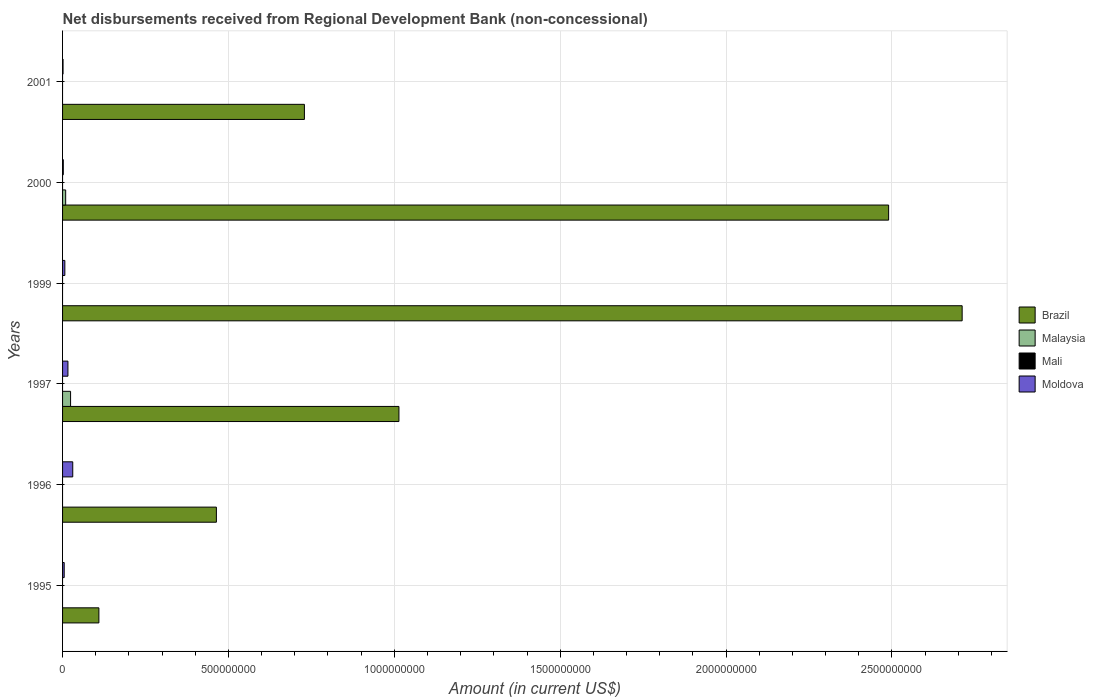How many different coloured bars are there?
Your answer should be very brief. 3. Are the number of bars per tick equal to the number of legend labels?
Your answer should be compact. No. Are the number of bars on each tick of the Y-axis equal?
Provide a succinct answer. No. How many bars are there on the 5th tick from the top?
Keep it short and to the point. 2. In how many cases, is the number of bars for a given year not equal to the number of legend labels?
Provide a short and direct response. 6. What is the amount of disbursements received from Regional Development Bank in Moldova in 1997?
Your response must be concise. 1.62e+07. Across all years, what is the maximum amount of disbursements received from Regional Development Bank in Brazil?
Ensure brevity in your answer.  2.71e+09. Across all years, what is the minimum amount of disbursements received from Regional Development Bank in Moldova?
Provide a succinct answer. 1.43e+06. What is the total amount of disbursements received from Regional Development Bank in Malaysia in the graph?
Make the answer very short. 3.35e+07. What is the difference between the amount of disbursements received from Regional Development Bank in Brazil in 1997 and that in 1999?
Make the answer very short. -1.70e+09. What is the difference between the amount of disbursements received from Regional Development Bank in Mali in 1996 and the amount of disbursements received from Regional Development Bank in Brazil in 1997?
Keep it short and to the point. -1.01e+09. In the year 2001, what is the difference between the amount of disbursements received from Regional Development Bank in Brazil and amount of disbursements received from Regional Development Bank in Moldova?
Provide a short and direct response. 7.28e+08. In how many years, is the amount of disbursements received from Regional Development Bank in Moldova greater than 300000000 US$?
Your answer should be very brief. 0. What is the ratio of the amount of disbursements received from Regional Development Bank in Moldova in 1995 to that in 1999?
Provide a short and direct response. 0.72. Is the amount of disbursements received from Regional Development Bank in Brazil in 1996 less than that in 1997?
Ensure brevity in your answer.  Yes. What is the difference between the highest and the second highest amount of disbursements received from Regional Development Bank in Moldova?
Your answer should be compact. 1.45e+07. What is the difference between the highest and the lowest amount of disbursements received from Regional Development Bank in Brazil?
Keep it short and to the point. 2.60e+09. Are all the bars in the graph horizontal?
Offer a terse response. Yes. What is the difference between two consecutive major ticks on the X-axis?
Provide a short and direct response. 5.00e+08. Does the graph contain any zero values?
Your response must be concise. Yes. Does the graph contain grids?
Offer a very short reply. Yes. How are the legend labels stacked?
Give a very brief answer. Vertical. What is the title of the graph?
Give a very brief answer. Net disbursements received from Regional Development Bank (non-concessional). Does "West Bank and Gaza" appear as one of the legend labels in the graph?
Provide a succinct answer. No. What is the label or title of the Y-axis?
Your answer should be very brief. Years. What is the Amount (in current US$) of Brazil in 1995?
Keep it short and to the point. 1.10e+08. What is the Amount (in current US$) of Malaysia in 1995?
Give a very brief answer. 0. What is the Amount (in current US$) in Mali in 1995?
Your answer should be compact. 0. What is the Amount (in current US$) in Moldova in 1995?
Give a very brief answer. 4.94e+06. What is the Amount (in current US$) of Brazil in 1996?
Your response must be concise. 4.64e+08. What is the Amount (in current US$) in Moldova in 1996?
Your answer should be compact. 3.07e+07. What is the Amount (in current US$) of Brazil in 1997?
Provide a succinct answer. 1.01e+09. What is the Amount (in current US$) in Malaysia in 1997?
Make the answer very short. 2.42e+07. What is the Amount (in current US$) of Moldova in 1997?
Make the answer very short. 1.62e+07. What is the Amount (in current US$) in Brazil in 1999?
Provide a succinct answer. 2.71e+09. What is the Amount (in current US$) in Mali in 1999?
Give a very brief answer. 0. What is the Amount (in current US$) of Moldova in 1999?
Provide a short and direct response. 6.86e+06. What is the Amount (in current US$) of Brazil in 2000?
Offer a very short reply. 2.49e+09. What is the Amount (in current US$) in Malaysia in 2000?
Ensure brevity in your answer.  9.38e+06. What is the Amount (in current US$) in Moldova in 2000?
Offer a very short reply. 2.23e+06. What is the Amount (in current US$) in Brazil in 2001?
Provide a succinct answer. 7.29e+08. What is the Amount (in current US$) of Malaysia in 2001?
Your answer should be very brief. 0. What is the Amount (in current US$) in Moldova in 2001?
Ensure brevity in your answer.  1.43e+06. Across all years, what is the maximum Amount (in current US$) of Brazil?
Your response must be concise. 2.71e+09. Across all years, what is the maximum Amount (in current US$) in Malaysia?
Make the answer very short. 2.42e+07. Across all years, what is the maximum Amount (in current US$) of Moldova?
Your answer should be very brief. 3.07e+07. Across all years, what is the minimum Amount (in current US$) of Brazil?
Offer a very short reply. 1.10e+08. Across all years, what is the minimum Amount (in current US$) of Malaysia?
Offer a very short reply. 0. Across all years, what is the minimum Amount (in current US$) of Moldova?
Offer a very short reply. 1.43e+06. What is the total Amount (in current US$) in Brazil in the graph?
Offer a terse response. 7.52e+09. What is the total Amount (in current US$) of Malaysia in the graph?
Provide a succinct answer. 3.35e+07. What is the total Amount (in current US$) of Moldova in the graph?
Provide a succinct answer. 6.23e+07. What is the difference between the Amount (in current US$) in Brazil in 1995 and that in 1996?
Provide a short and direct response. -3.54e+08. What is the difference between the Amount (in current US$) of Moldova in 1995 and that in 1996?
Your response must be concise. -2.58e+07. What is the difference between the Amount (in current US$) of Brazil in 1995 and that in 1997?
Your response must be concise. -9.04e+08. What is the difference between the Amount (in current US$) of Moldova in 1995 and that in 1997?
Ensure brevity in your answer.  -1.12e+07. What is the difference between the Amount (in current US$) of Brazil in 1995 and that in 1999?
Offer a very short reply. -2.60e+09. What is the difference between the Amount (in current US$) in Moldova in 1995 and that in 1999?
Make the answer very short. -1.91e+06. What is the difference between the Amount (in current US$) of Brazil in 1995 and that in 2000?
Your response must be concise. -2.38e+09. What is the difference between the Amount (in current US$) in Moldova in 1995 and that in 2000?
Offer a very short reply. 2.72e+06. What is the difference between the Amount (in current US$) in Brazil in 1995 and that in 2001?
Provide a short and direct response. -6.20e+08. What is the difference between the Amount (in current US$) in Moldova in 1995 and that in 2001?
Offer a very short reply. 3.52e+06. What is the difference between the Amount (in current US$) in Brazil in 1996 and that in 1997?
Offer a very short reply. -5.50e+08. What is the difference between the Amount (in current US$) of Moldova in 1996 and that in 1997?
Ensure brevity in your answer.  1.45e+07. What is the difference between the Amount (in current US$) of Brazil in 1996 and that in 1999?
Provide a short and direct response. -2.25e+09. What is the difference between the Amount (in current US$) of Moldova in 1996 and that in 1999?
Your answer should be compact. 2.38e+07. What is the difference between the Amount (in current US$) in Brazil in 1996 and that in 2000?
Provide a succinct answer. -2.03e+09. What is the difference between the Amount (in current US$) in Moldova in 1996 and that in 2000?
Offer a terse response. 2.85e+07. What is the difference between the Amount (in current US$) of Brazil in 1996 and that in 2001?
Keep it short and to the point. -2.65e+08. What is the difference between the Amount (in current US$) in Moldova in 1996 and that in 2001?
Ensure brevity in your answer.  2.93e+07. What is the difference between the Amount (in current US$) in Brazil in 1997 and that in 1999?
Your response must be concise. -1.70e+09. What is the difference between the Amount (in current US$) of Moldova in 1997 and that in 1999?
Provide a short and direct response. 9.32e+06. What is the difference between the Amount (in current US$) of Brazil in 1997 and that in 2000?
Your answer should be compact. -1.48e+09. What is the difference between the Amount (in current US$) in Malaysia in 1997 and that in 2000?
Provide a succinct answer. 1.48e+07. What is the difference between the Amount (in current US$) in Moldova in 1997 and that in 2000?
Offer a terse response. 1.39e+07. What is the difference between the Amount (in current US$) of Brazil in 1997 and that in 2001?
Provide a succinct answer. 2.85e+08. What is the difference between the Amount (in current US$) in Moldova in 1997 and that in 2001?
Your response must be concise. 1.47e+07. What is the difference between the Amount (in current US$) of Brazil in 1999 and that in 2000?
Your response must be concise. 2.22e+08. What is the difference between the Amount (in current US$) in Moldova in 1999 and that in 2000?
Offer a very short reply. 4.63e+06. What is the difference between the Amount (in current US$) in Brazil in 1999 and that in 2001?
Provide a succinct answer. 1.98e+09. What is the difference between the Amount (in current US$) of Moldova in 1999 and that in 2001?
Your response must be concise. 5.43e+06. What is the difference between the Amount (in current US$) of Brazil in 2000 and that in 2001?
Your answer should be compact. 1.76e+09. What is the difference between the Amount (in current US$) of Moldova in 2000 and that in 2001?
Your response must be concise. 8.03e+05. What is the difference between the Amount (in current US$) of Brazil in 1995 and the Amount (in current US$) of Moldova in 1996?
Your answer should be compact. 7.88e+07. What is the difference between the Amount (in current US$) of Brazil in 1995 and the Amount (in current US$) of Malaysia in 1997?
Your answer should be very brief. 8.53e+07. What is the difference between the Amount (in current US$) in Brazil in 1995 and the Amount (in current US$) in Moldova in 1997?
Give a very brief answer. 9.33e+07. What is the difference between the Amount (in current US$) in Brazil in 1995 and the Amount (in current US$) in Moldova in 1999?
Offer a terse response. 1.03e+08. What is the difference between the Amount (in current US$) in Brazil in 1995 and the Amount (in current US$) in Malaysia in 2000?
Your response must be concise. 1.00e+08. What is the difference between the Amount (in current US$) of Brazil in 1995 and the Amount (in current US$) of Moldova in 2000?
Give a very brief answer. 1.07e+08. What is the difference between the Amount (in current US$) in Brazil in 1995 and the Amount (in current US$) in Moldova in 2001?
Give a very brief answer. 1.08e+08. What is the difference between the Amount (in current US$) in Brazil in 1996 and the Amount (in current US$) in Malaysia in 1997?
Make the answer very short. 4.40e+08. What is the difference between the Amount (in current US$) of Brazil in 1996 and the Amount (in current US$) of Moldova in 1997?
Your answer should be very brief. 4.48e+08. What is the difference between the Amount (in current US$) of Brazil in 1996 and the Amount (in current US$) of Moldova in 1999?
Make the answer very short. 4.57e+08. What is the difference between the Amount (in current US$) of Brazil in 1996 and the Amount (in current US$) of Malaysia in 2000?
Ensure brevity in your answer.  4.54e+08. What is the difference between the Amount (in current US$) in Brazil in 1996 and the Amount (in current US$) in Moldova in 2000?
Offer a very short reply. 4.61e+08. What is the difference between the Amount (in current US$) in Brazil in 1996 and the Amount (in current US$) in Moldova in 2001?
Keep it short and to the point. 4.62e+08. What is the difference between the Amount (in current US$) of Brazil in 1997 and the Amount (in current US$) of Moldova in 1999?
Provide a succinct answer. 1.01e+09. What is the difference between the Amount (in current US$) of Malaysia in 1997 and the Amount (in current US$) of Moldova in 1999?
Your answer should be very brief. 1.73e+07. What is the difference between the Amount (in current US$) in Brazil in 1997 and the Amount (in current US$) in Malaysia in 2000?
Make the answer very short. 1.00e+09. What is the difference between the Amount (in current US$) of Brazil in 1997 and the Amount (in current US$) of Moldova in 2000?
Your response must be concise. 1.01e+09. What is the difference between the Amount (in current US$) of Malaysia in 1997 and the Amount (in current US$) of Moldova in 2000?
Offer a terse response. 2.19e+07. What is the difference between the Amount (in current US$) in Brazil in 1997 and the Amount (in current US$) in Moldova in 2001?
Ensure brevity in your answer.  1.01e+09. What is the difference between the Amount (in current US$) in Malaysia in 1997 and the Amount (in current US$) in Moldova in 2001?
Your response must be concise. 2.27e+07. What is the difference between the Amount (in current US$) of Brazil in 1999 and the Amount (in current US$) of Malaysia in 2000?
Make the answer very short. 2.70e+09. What is the difference between the Amount (in current US$) in Brazil in 1999 and the Amount (in current US$) in Moldova in 2000?
Your answer should be compact. 2.71e+09. What is the difference between the Amount (in current US$) of Brazil in 1999 and the Amount (in current US$) of Moldova in 2001?
Make the answer very short. 2.71e+09. What is the difference between the Amount (in current US$) in Brazil in 2000 and the Amount (in current US$) in Moldova in 2001?
Offer a very short reply. 2.49e+09. What is the difference between the Amount (in current US$) of Malaysia in 2000 and the Amount (in current US$) of Moldova in 2001?
Provide a short and direct response. 7.95e+06. What is the average Amount (in current US$) in Brazil per year?
Provide a short and direct response. 1.25e+09. What is the average Amount (in current US$) of Malaysia per year?
Provide a short and direct response. 5.59e+06. What is the average Amount (in current US$) in Mali per year?
Make the answer very short. 0. What is the average Amount (in current US$) in Moldova per year?
Your answer should be compact. 1.04e+07. In the year 1995, what is the difference between the Amount (in current US$) in Brazil and Amount (in current US$) in Moldova?
Ensure brevity in your answer.  1.05e+08. In the year 1996, what is the difference between the Amount (in current US$) of Brazil and Amount (in current US$) of Moldova?
Ensure brevity in your answer.  4.33e+08. In the year 1997, what is the difference between the Amount (in current US$) in Brazil and Amount (in current US$) in Malaysia?
Ensure brevity in your answer.  9.90e+08. In the year 1997, what is the difference between the Amount (in current US$) in Brazil and Amount (in current US$) in Moldova?
Your answer should be very brief. 9.98e+08. In the year 1997, what is the difference between the Amount (in current US$) in Malaysia and Amount (in current US$) in Moldova?
Keep it short and to the point. 7.99e+06. In the year 1999, what is the difference between the Amount (in current US$) in Brazil and Amount (in current US$) in Moldova?
Ensure brevity in your answer.  2.70e+09. In the year 2000, what is the difference between the Amount (in current US$) of Brazil and Amount (in current US$) of Malaysia?
Your answer should be very brief. 2.48e+09. In the year 2000, what is the difference between the Amount (in current US$) in Brazil and Amount (in current US$) in Moldova?
Your response must be concise. 2.49e+09. In the year 2000, what is the difference between the Amount (in current US$) of Malaysia and Amount (in current US$) of Moldova?
Give a very brief answer. 7.15e+06. In the year 2001, what is the difference between the Amount (in current US$) of Brazil and Amount (in current US$) of Moldova?
Your answer should be compact. 7.28e+08. What is the ratio of the Amount (in current US$) in Brazil in 1995 to that in 1996?
Your answer should be very brief. 0.24. What is the ratio of the Amount (in current US$) of Moldova in 1995 to that in 1996?
Your answer should be very brief. 0.16. What is the ratio of the Amount (in current US$) of Brazil in 1995 to that in 1997?
Give a very brief answer. 0.11. What is the ratio of the Amount (in current US$) of Moldova in 1995 to that in 1997?
Your answer should be very brief. 0.31. What is the ratio of the Amount (in current US$) of Brazil in 1995 to that in 1999?
Provide a short and direct response. 0.04. What is the ratio of the Amount (in current US$) of Moldova in 1995 to that in 1999?
Make the answer very short. 0.72. What is the ratio of the Amount (in current US$) in Brazil in 1995 to that in 2000?
Provide a short and direct response. 0.04. What is the ratio of the Amount (in current US$) in Moldova in 1995 to that in 2000?
Make the answer very short. 2.22. What is the ratio of the Amount (in current US$) in Brazil in 1995 to that in 2001?
Your answer should be compact. 0.15. What is the ratio of the Amount (in current US$) of Moldova in 1995 to that in 2001?
Provide a succinct answer. 3.47. What is the ratio of the Amount (in current US$) in Brazil in 1996 to that in 1997?
Ensure brevity in your answer.  0.46. What is the ratio of the Amount (in current US$) of Moldova in 1996 to that in 1997?
Provide a succinct answer. 1.9. What is the ratio of the Amount (in current US$) of Brazil in 1996 to that in 1999?
Keep it short and to the point. 0.17. What is the ratio of the Amount (in current US$) in Moldova in 1996 to that in 1999?
Your response must be concise. 4.48. What is the ratio of the Amount (in current US$) in Brazil in 1996 to that in 2000?
Your response must be concise. 0.19. What is the ratio of the Amount (in current US$) of Moldova in 1996 to that in 2000?
Provide a short and direct response. 13.77. What is the ratio of the Amount (in current US$) in Brazil in 1996 to that in 2001?
Make the answer very short. 0.64. What is the ratio of the Amount (in current US$) of Moldova in 1996 to that in 2001?
Give a very brief answer. 21.51. What is the ratio of the Amount (in current US$) of Brazil in 1997 to that in 1999?
Offer a very short reply. 0.37. What is the ratio of the Amount (in current US$) of Moldova in 1997 to that in 1999?
Give a very brief answer. 2.36. What is the ratio of the Amount (in current US$) of Brazil in 1997 to that in 2000?
Provide a short and direct response. 0.41. What is the ratio of the Amount (in current US$) in Malaysia in 1997 to that in 2000?
Ensure brevity in your answer.  2.58. What is the ratio of the Amount (in current US$) of Moldova in 1997 to that in 2000?
Give a very brief answer. 7.25. What is the ratio of the Amount (in current US$) of Brazil in 1997 to that in 2001?
Offer a terse response. 1.39. What is the ratio of the Amount (in current US$) in Moldova in 1997 to that in 2001?
Offer a very short reply. 11.33. What is the ratio of the Amount (in current US$) in Brazil in 1999 to that in 2000?
Give a very brief answer. 1.09. What is the ratio of the Amount (in current US$) of Moldova in 1999 to that in 2000?
Offer a very short reply. 3.07. What is the ratio of the Amount (in current US$) of Brazil in 1999 to that in 2001?
Your answer should be very brief. 3.72. What is the ratio of the Amount (in current US$) in Moldova in 1999 to that in 2001?
Make the answer very short. 4.8. What is the ratio of the Amount (in current US$) in Brazil in 2000 to that in 2001?
Offer a very short reply. 3.42. What is the ratio of the Amount (in current US$) of Moldova in 2000 to that in 2001?
Ensure brevity in your answer.  1.56. What is the difference between the highest and the second highest Amount (in current US$) of Brazil?
Keep it short and to the point. 2.22e+08. What is the difference between the highest and the second highest Amount (in current US$) in Moldova?
Your answer should be very brief. 1.45e+07. What is the difference between the highest and the lowest Amount (in current US$) in Brazil?
Your response must be concise. 2.60e+09. What is the difference between the highest and the lowest Amount (in current US$) in Malaysia?
Give a very brief answer. 2.42e+07. What is the difference between the highest and the lowest Amount (in current US$) in Moldova?
Ensure brevity in your answer.  2.93e+07. 